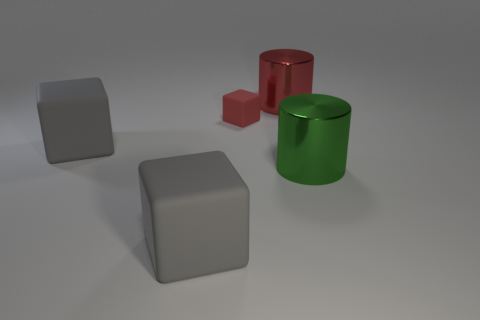Are there any cubes behind the green metal cylinder?
Your answer should be very brief. Yes. Is the material of the large green cylinder the same as the small object?
Make the answer very short. No. The other big thing that is the same shape as the big red shiny object is what color?
Keep it short and to the point. Green. There is a block that is in front of the big green thing; does it have the same color as the tiny matte block?
Ensure brevity in your answer.  No. What shape is the object that is the same color as the tiny block?
Offer a terse response. Cylinder. How many red things have the same material as the large green cylinder?
Ensure brevity in your answer.  1. There is a green metallic thing; what number of gray things are on the right side of it?
Provide a short and direct response. 0. The red rubber thing is what size?
Provide a succinct answer. Small. The other cylinder that is the same size as the red cylinder is what color?
Your response must be concise. Green. Is there a big shiny cylinder that has the same color as the tiny block?
Your answer should be compact. Yes. 